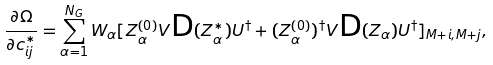<formula> <loc_0><loc_0><loc_500><loc_500>\frac { \partial \Omega } { \partial c ^ { * } _ { i j } } = \sum _ { \alpha = 1 } ^ { N _ { G } } W _ { \alpha } [ Z ^ { ( 0 ) } _ { \alpha } V \text {D} ( Z ^ { * } _ { \alpha } ) U ^ { \dagger } + ( Z ^ { ( 0 ) } _ { \alpha } ) ^ { \dagger } V \text {D} ( Z _ { \alpha } ) U ^ { \dagger } ] _ { M + i , M + j } ,</formula> 